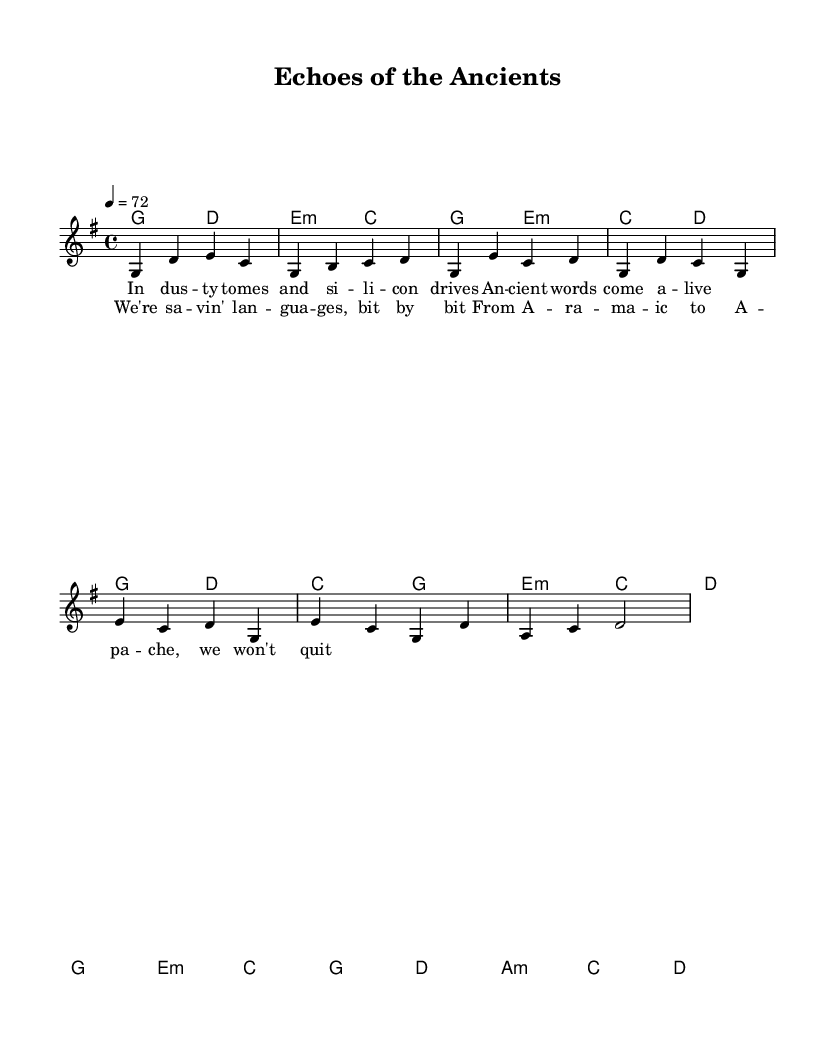What is the key signature of this music? The key signature is G major, which has one sharp (F#). This can be determined by looking at the key signature indicated at the beginning of the score.
Answer: G major What is the time signature of this music? The time signature is 4/4, which means there are four beats per measure and a quarter note receives one beat. This is indicated at the beginning of the score.
Answer: 4/4 What is the tempo marking? The tempo marking is 72 beats per minute, indicated by the tempo terms at the beginning of the score as "4 = 72". This indicates the speed of the piece.
Answer: 72 How many measures are in the chorus? The chorus consists of four measures, as counted by locating the musical notation for the chorus section and counting the bar lines.
Answer: 4 What are the two main themes presented in the lyrics? The lyrics focus on preserving ancient languages and the effort to save them, specifically by referencing various languages. This can be deduced from the content of the lyrics in both the verse and chorus sections.
Answer: Preservation, languages How does the harmony relate to the melody in the chorus? The harmony supports the melody by providing foundational chords that enrich the vocal line. For example, the harmony for the chorus follows the chord progression that aligns with the melodic notes, ensuring the chord structures complement the vocal melody. This cohesive relationship can be analyzed through looking at how chords correspond to melodies within the chorus section.
Answer: Complementary 